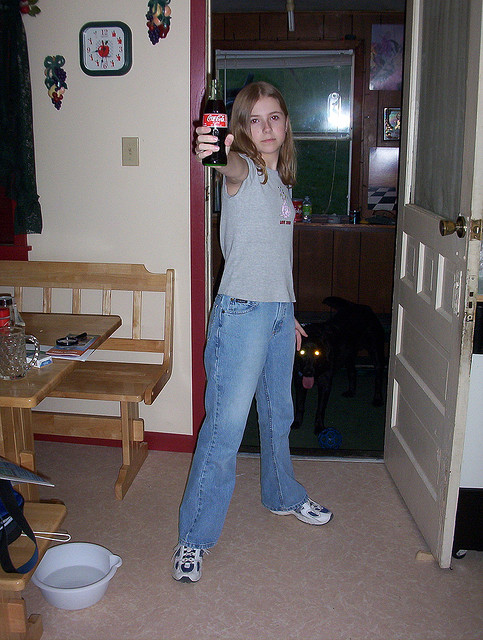<image>What game system are the kids playing? There is no game system the kids are playing. It seems they are not playing one. What game system are the kids playing? I don't know what game system the kids are playing. It can be either 'Wii' or 'Nintendo'. 